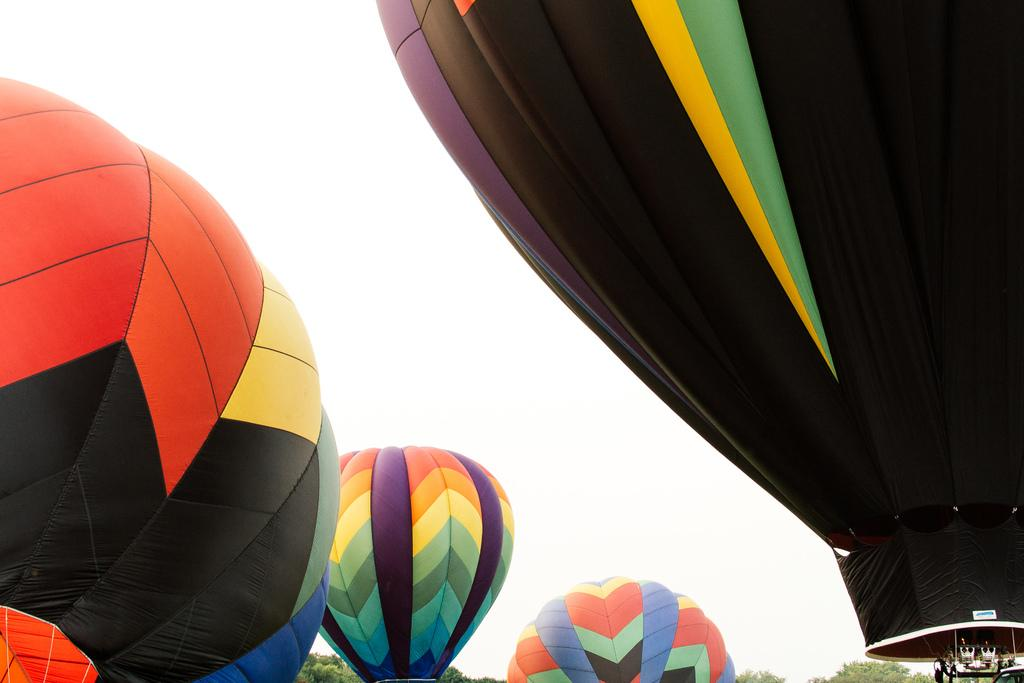What is the main subject of the image? The main subject of the image is hot air balloons. Can you describe the colors of the hot air balloons? The hot air balloons are in orange, red, black, yellow, and green colors. What can be seen in the background of the image? There are trees and the sky visible in the background of the image. What type of pump is being used to inflate the hot air balloons in the image? There is no pump visible in the image, and the hot air balloons are already inflated. How is the glue being applied to the hot air balloons in the image? There is no glue or any indication of glue application in the image. 